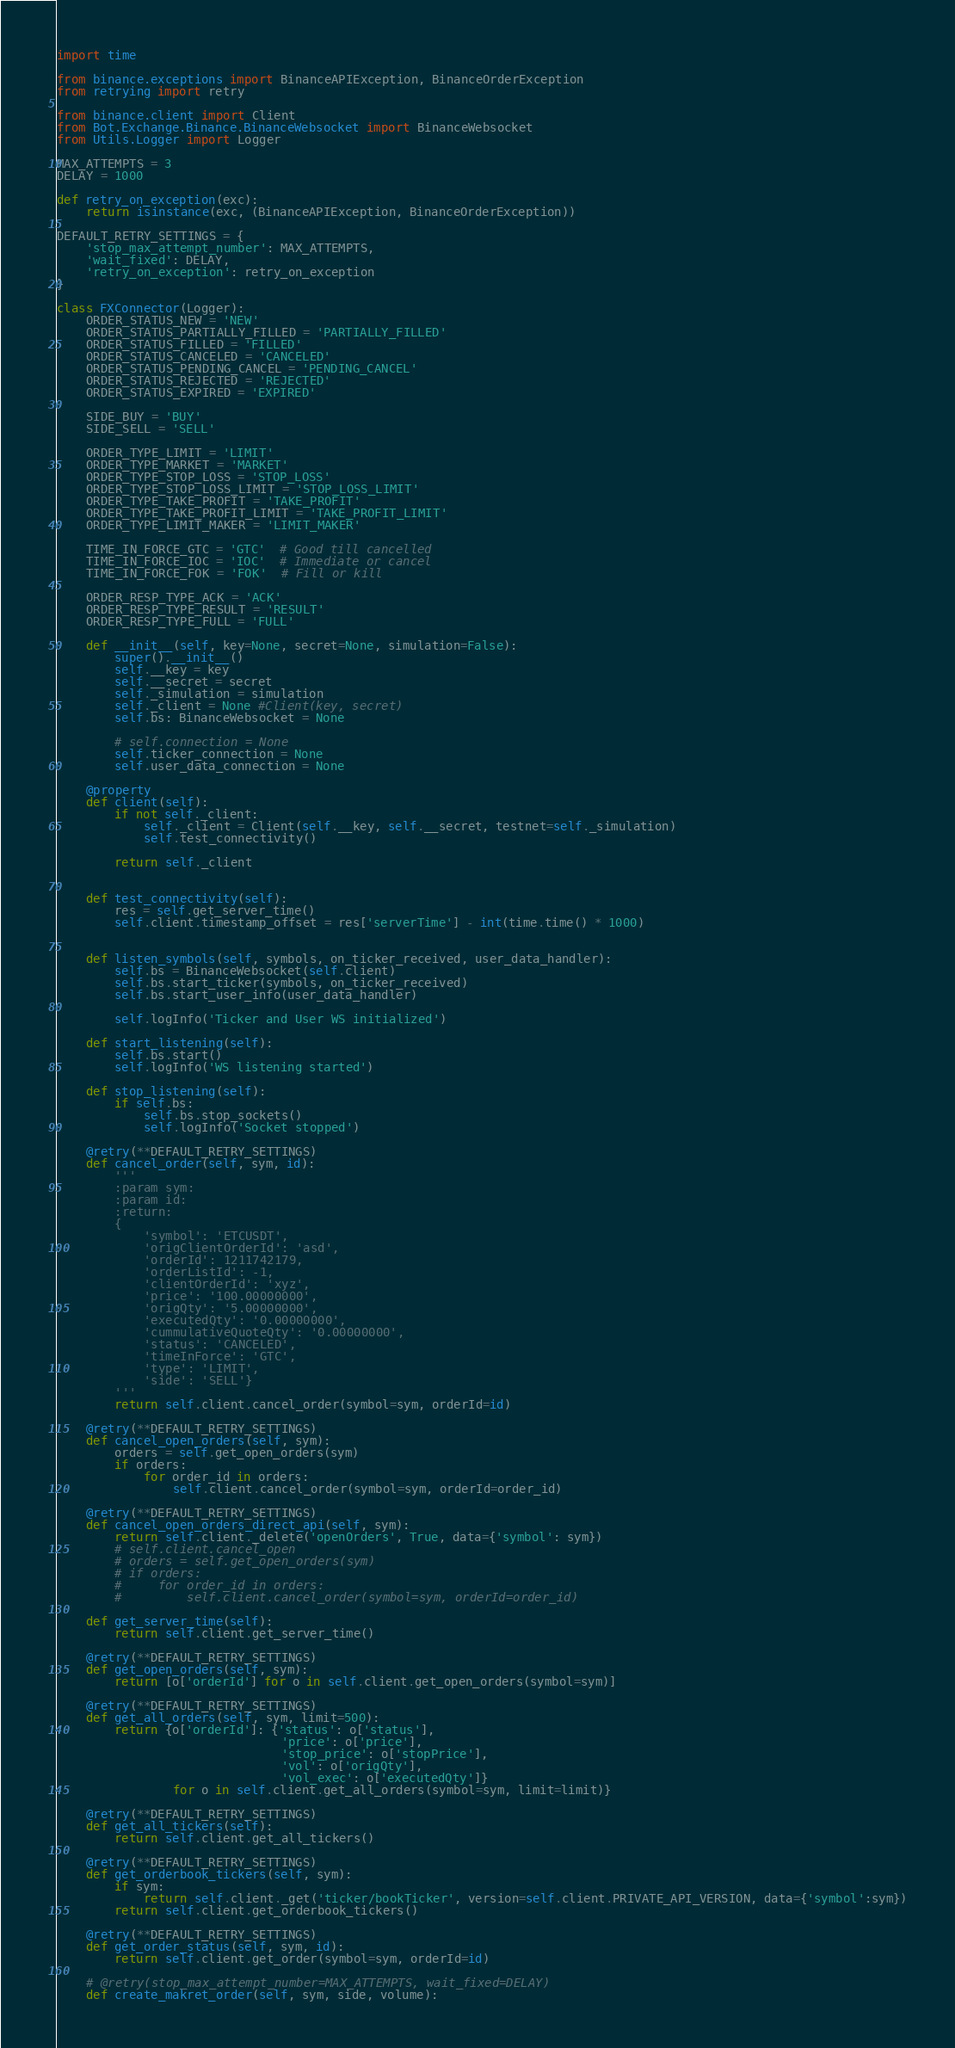<code> <loc_0><loc_0><loc_500><loc_500><_Python_>import time

from binance.exceptions import BinanceAPIException, BinanceOrderException
from retrying import retry

from binance.client import Client
from Bot.Exchange.Binance.BinanceWebsocket import BinanceWebsocket
from Utils.Logger import Logger

MAX_ATTEMPTS = 3
DELAY = 1000

def retry_on_exception(exc):
    return isinstance(exc, (BinanceAPIException, BinanceOrderException))

DEFAULT_RETRY_SETTINGS = {
    'stop_max_attempt_number': MAX_ATTEMPTS,
    'wait_fixed': DELAY,
    'retry_on_exception': retry_on_exception
}

class FXConnector(Logger):
    ORDER_STATUS_NEW = 'NEW'
    ORDER_STATUS_PARTIALLY_FILLED = 'PARTIALLY_FILLED'
    ORDER_STATUS_FILLED = 'FILLED'
    ORDER_STATUS_CANCELED = 'CANCELED'
    ORDER_STATUS_PENDING_CANCEL = 'PENDING_CANCEL'
    ORDER_STATUS_REJECTED = 'REJECTED'
    ORDER_STATUS_EXPIRED = 'EXPIRED'

    SIDE_BUY = 'BUY'
    SIDE_SELL = 'SELL'

    ORDER_TYPE_LIMIT = 'LIMIT'
    ORDER_TYPE_MARKET = 'MARKET'
    ORDER_TYPE_STOP_LOSS = 'STOP_LOSS'
    ORDER_TYPE_STOP_LOSS_LIMIT = 'STOP_LOSS_LIMIT'
    ORDER_TYPE_TAKE_PROFIT = 'TAKE_PROFIT'
    ORDER_TYPE_TAKE_PROFIT_LIMIT = 'TAKE_PROFIT_LIMIT'
    ORDER_TYPE_LIMIT_MAKER = 'LIMIT_MAKER'

    TIME_IN_FORCE_GTC = 'GTC'  # Good till cancelled
    TIME_IN_FORCE_IOC = 'IOC'  # Immediate or cancel
    TIME_IN_FORCE_FOK = 'FOK'  # Fill or kill

    ORDER_RESP_TYPE_ACK = 'ACK'
    ORDER_RESP_TYPE_RESULT = 'RESULT'
    ORDER_RESP_TYPE_FULL = 'FULL'

    def __init__(self, key=None, secret=None, simulation=False):
        super().__init__()
        self.__key = key
        self.__secret = secret
        self._simulation = simulation
        self._client = None #Client(key, secret)
        self.bs: BinanceWebsocket = None

        # self.connection = None
        self.ticker_connection = None
        self.user_data_connection = None

    @property
    def client(self):
        if not self._client:
            self._client = Client(self.__key, self.__secret, testnet=self._simulation)
            self.test_connectivity()

        return self._client


    def test_connectivity(self):
        res = self.get_server_time()
        self.client.timestamp_offset = res['serverTime'] - int(time.time() * 1000)


    def listen_symbols(self, symbols, on_ticker_received, user_data_handler):
        self.bs = BinanceWebsocket(self.client)
        self.bs.start_ticker(symbols, on_ticker_received)
        self.bs.start_user_info(user_data_handler)

        self.logInfo('Ticker and User WS initialized')

    def start_listening(self):
        self.bs.start()
        self.logInfo('WS listening started')

    def stop_listening(self):
        if self.bs:
            self.bs.stop_sockets()
            self.logInfo('Socket stopped')

    @retry(**DEFAULT_RETRY_SETTINGS)
    def cancel_order(self, sym, id):
        '''
        :param sym:
        :param id:
        :return:
        {
            'symbol': 'ETCUSDT',
            'origClientOrderId': 'asd',
            'orderId': 1211742179,
            'orderListId': -1,
            'clientOrderId': 'xyz',
            'price': '100.00000000',
            'origQty': '5.00000000',
            'executedQty': '0.00000000',
            'cummulativeQuoteQty': '0.00000000',
            'status': 'CANCELED',
            'timeInForce': 'GTC',
            'type': 'LIMIT',
            'side': 'SELL'}
        '''
        return self.client.cancel_order(symbol=sym, orderId=id)

    @retry(**DEFAULT_RETRY_SETTINGS)
    def cancel_open_orders(self, sym):
        orders = self.get_open_orders(sym)
        if orders:
            for order_id in orders:
                self.client.cancel_order(symbol=sym, orderId=order_id)

    @retry(**DEFAULT_RETRY_SETTINGS)
    def cancel_open_orders_direct_api(self, sym):
        return self.client._delete('openOrders', True, data={'symbol': sym})
        # self.client.cancel_open
        # orders = self.get_open_orders(sym)
        # if orders:
        #     for order_id in orders:
        #         self.client.cancel_order(symbol=sym, orderId=order_id)

    def get_server_time(self):
        return self.client.get_server_time()

    @retry(**DEFAULT_RETRY_SETTINGS)
    def get_open_orders(self, sym):
        return [o['orderId'] for o in self.client.get_open_orders(symbol=sym)]

    @retry(**DEFAULT_RETRY_SETTINGS)
    def get_all_orders(self, sym, limit=500):
        return {o['orderId']: {'status': o['status'],
                               'price': o['price'],
                               'stop_price': o['stopPrice'],
                               'vol': o['origQty'],
                               'vol_exec': o['executedQty']}
                for o in self.client.get_all_orders(symbol=sym, limit=limit)}

    @retry(**DEFAULT_RETRY_SETTINGS)
    def get_all_tickers(self):
        return self.client.get_all_tickers()

    @retry(**DEFAULT_RETRY_SETTINGS)
    def get_orderbook_tickers(self, sym):
        if sym:
            return self.client._get('ticker/bookTicker', version=self.client.PRIVATE_API_VERSION, data={'symbol':sym})
        return self.client.get_orderbook_tickers()

    @retry(**DEFAULT_RETRY_SETTINGS)
    def get_order_status(self, sym, id):
        return self.client.get_order(symbol=sym, orderId=id)

    # @retry(stop_max_attempt_number=MAX_ATTEMPTS, wait_fixed=DELAY)
    def create_makret_order(self, sym, side, volume):</code> 